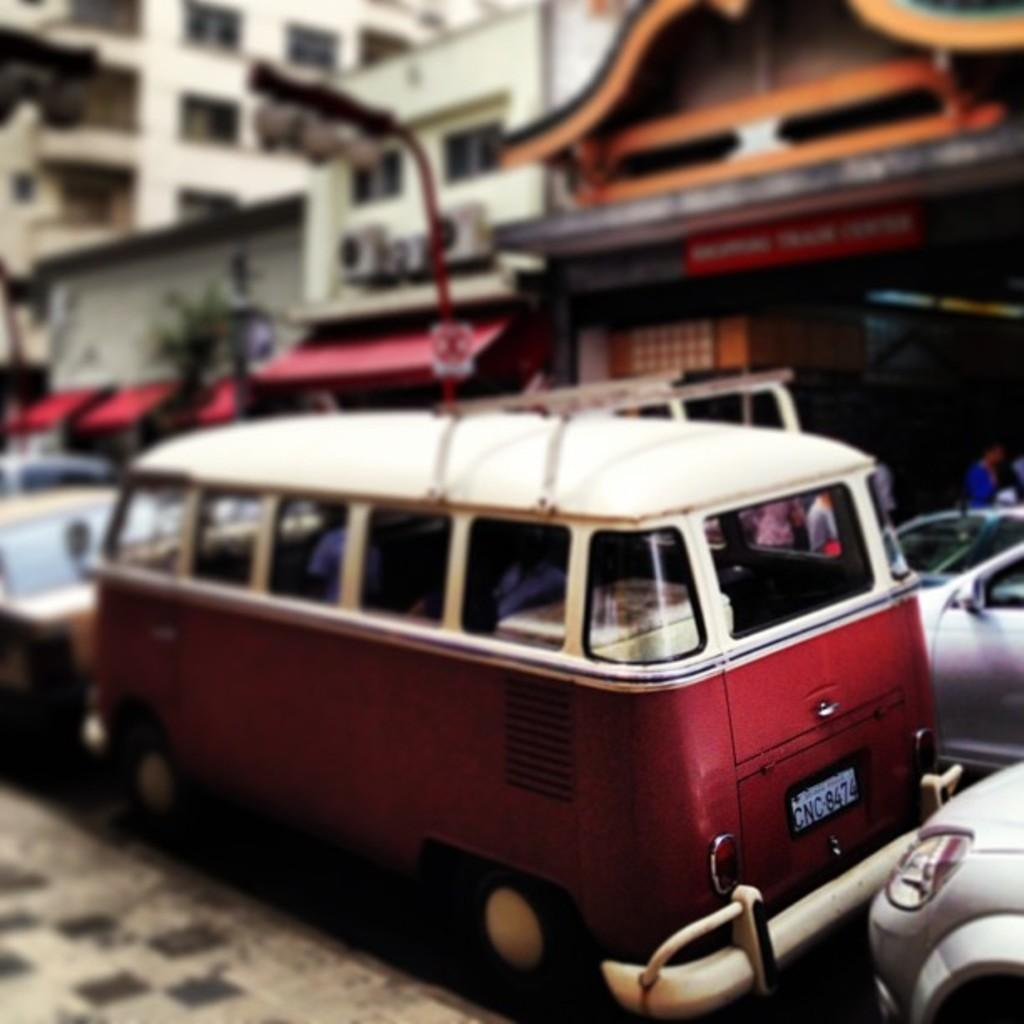What types of objects are present in the image? There are vehicles, traffic lights, and buildings in the image. What might control the flow of traffic in the image? The traffic lights in the image might control the flow of traffic. What can be seen in the background of the image? The background of the image is blurred. What type of crime is being committed in the image? There is no indication of any crime being committed in the image. What knowledge can be gained from the image? The image provides information about the presence of vehicles, traffic lights, and buildings, but it does not convey any specific knowledge beyond that. 